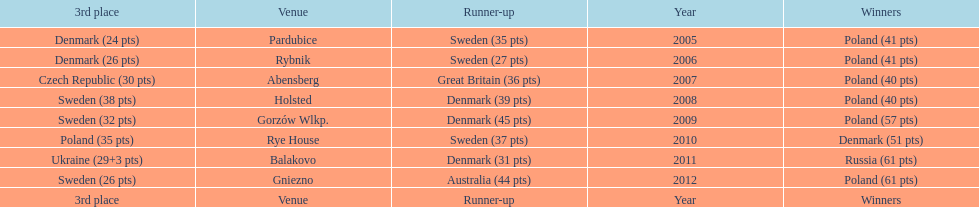From 2005-2012, in the team speedway junior world championship, how many more first place wins than all other teams put together? Poland. 